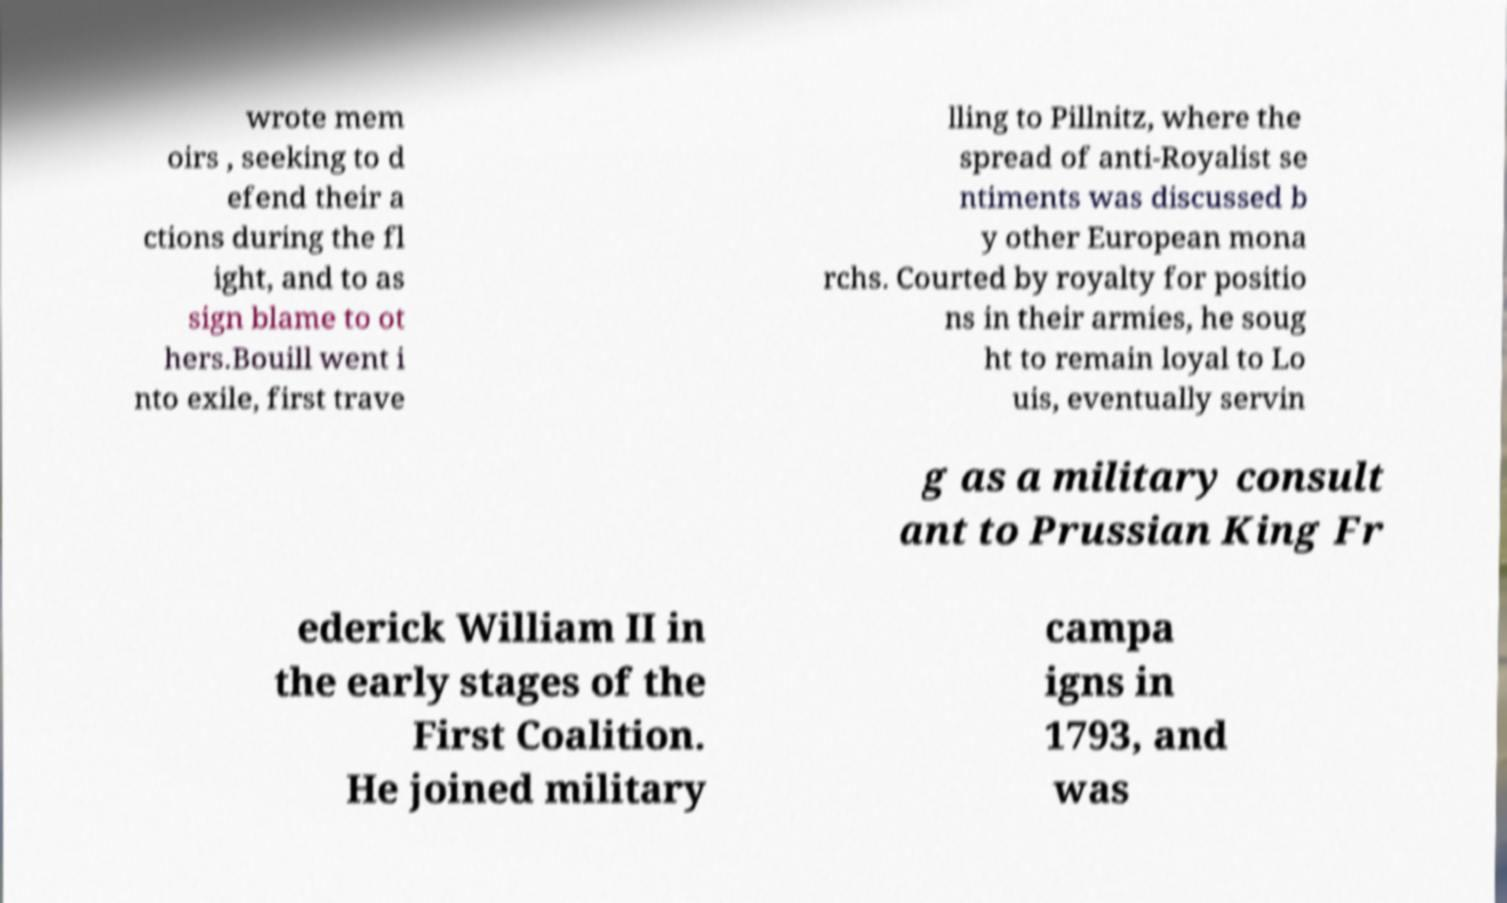Please identify and transcribe the text found in this image. wrote mem oirs , seeking to d efend their a ctions during the fl ight, and to as sign blame to ot hers.Bouill went i nto exile, first trave lling to Pillnitz, where the spread of anti-Royalist se ntiments was discussed b y other European mona rchs. Courted by royalty for positio ns in their armies, he soug ht to remain loyal to Lo uis, eventually servin g as a military consult ant to Prussian King Fr ederick William II in the early stages of the First Coalition. He joined military campa igns in 1793, and was 